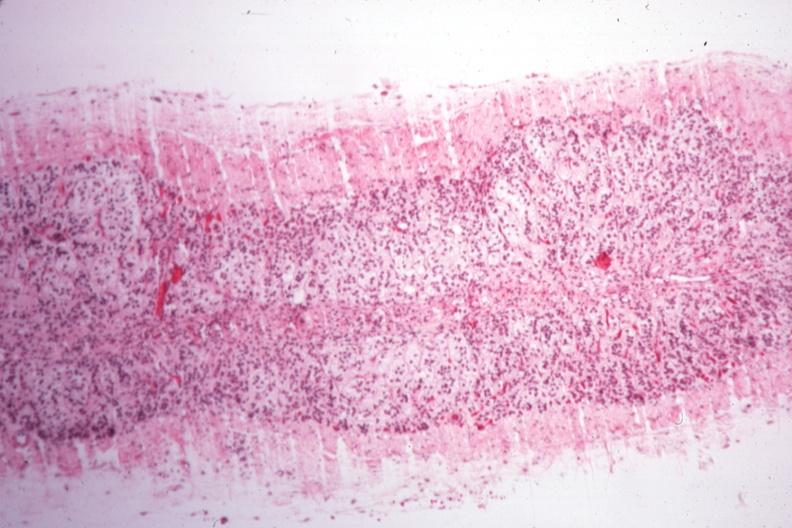s chromophobe adenoma present?
Answer the question using a single word or phrase. No 